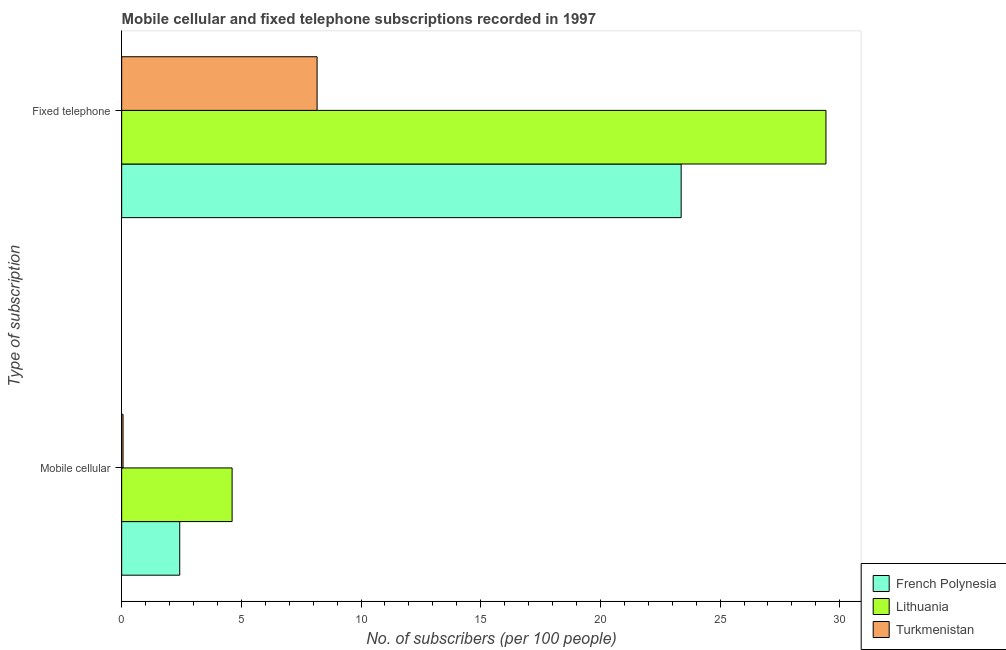Are the number of bars per tick equal to the number of legend labels?
Offer a terse response. Yes. What is the label of the 2nd group of bars from the top?
Keep it short and to the point. Mobile cellular. What is the number of fixed telephone subscribers in Lithuania?
Your answer should be compact. 29.42. Across all countries, what is the maximum number of fixed telephone subscribers?
Your answer should be very brief. 29.42. Across all countries, what is the minimum number of fixed telephone subscribers?
Keep it short and to the point. 8.16. In which country was the number of fixed telephone subscribers maximum?
Give a very brief answer. Lithuania. In which country was the number of fixed telephone subscribers minimum?
Your answer should be compact. Turkmenistan. What is the total number of mobile cellular subscribers in the graph?
Offer a very short reply. 7.1. What is the difference between the number of mobile cellular subscribers in French Polynesia and that in Lithuania?
Give a very brief answer. -2.19. What is the difference between the number of mobile cellular subscribers in Turkmenistan and the number of fixed telephone subscribers in Lithuania?
Your answer should be compact. -29.37. What is the average number of mobile cellular subscribers per country?
Provide a succinct answer. 2.37. What is the difference between the number of fixed telephone subscribers and number of mobile cellular subscribers in Turkmenistan?
Offer a very short reply. 8.11. In how many countries, is the number of fixed telephone subscribers greater than 19 ?
Give a very brief answer. 2. What is the ratio of the number of fixed telephone subscribers in Turkmenistan to that in French Polynesia?
Offer a very short reply. 0.35. Is the number of mobile cellular subscribers in Lithuania less than that in French Polynesia?
Provide a succinct answer. No. In how many countries, is the number of mobile cellular subscribers greater than the average number of mobile cellular subscribers taken over all countries?
Provide a succinct answer. 2. What does the 2nd bar from the top in Mobile cellular represents?
Offer a very short reply. Lithuania. What does the 1st bar from the bottom in Mobile cellular represents?
Offer a terse response. French Polynesia. Are all the bars in the graph horizontal?
Provide a succinct answer. Yes. How many countries are there in the graph?
Keep it short and to the point. 3. What is the difference between two consecutive major ticks on the X-axis?
Offer a very short reply. 5. Does the graph contain any zero values?
Offer a very short reply. No. Does the graph contain grids?
Your answer should be very brief. No. What is the title of the graph?
Your answer should be very brief. Mobile cellular and fixed telephone subscriptions recorded in 1997. What is the label or title of the X-axis?
Provide a short and direct response. No. of subscribers (per 100 people). What is the label or title of the Y-axis?
Provide a succinct answer. Type of subscription. What is the No. of subscribers (per 100 people) of French Polynesia in Mobile cellular?
Make the answer very short. 2.43. What is the No. of subscribers (per 100 people) in Lithuania in Mobile cellular?
Make the answer very short. 4.61. What is the No. of subscribers (per 100 people) in Turkmenistan in Mobile cellular?
Provide a short and direct response. 0.06. What is the No. of subscribers (per 100 people) in French Polynesia in Fixed telephone?
Give a very brief answer. 23.37. What is the No. of subscribers (per 100 people) of Lithuania in Fixed telephone?
Provide a succinct answer. 29.42. What is the No. of subscribers (per 100 people) in Turkmenistan in Fixed telephone?
Your answer should be very brief. 8.16. Across all Type of subscription, what is the maximum No. of subscribers (per 100 people) in French Polynesia?
Your response must be concise. 23.37. Across all Type of subscription, what is the maximum No. of subscribers (per 100 people) of Lithuania?
Offer a very short reply. 29.42. Across all Type of subscription, what is the maximum No. of subscribers (per 100 people) in Turkmenistan?
Your answer should be very brief. 8.16. Across all Type of subscription, what is the minimum No. of subscribers (per 100 people) in French Polynesia?
Your answer should be very brief. 2.43. Across all Type of subscription, what is the minimum No. of subscribers (per 100 people) of Lithuania?
Provide a succinct answer. 4.61. Across all Type of subscription, what is the minimum No. of subscribers (per 100 people) of Turkmenistan?
Offer a very short reply. 0.06. What is the total No. of subscribers (per 100 people) of French Polynesia in the graph?
Provide a short and direct response. 25.8. What is the total No. of subscribers (per 100 people) of Lithuania in the graph?
Your response must be concise. 34.04. What is the total No. of subscribers (per 100 people) of Turkmenistan in the graph?
Keep it short and to the point. 8.22. What is the difference between the No. of subscribers (per 100 people) of French Polynesia in Mobile cellular and that in Fixed telephone?
Your answer should be compact. -20.95. What is the difference between the No. of subscribers (per 100 people) of Lithuania in Mobile cellular and that in Fixed telephone?
Keep it short and to the point. -24.81. What is the difference between the No. of subscribers (per 100 people) in Turkmenistan in Mobile cellular and that in Fixed telephone?
Offer a terse response. -8.11. What is the difference between the No. of subscribers (per 100 people) of French Polynesia in Mobile cellular and the No. of subscribers (per 100 people) of Lithuania in Fixed telephone?
Provide a short and direct response. -27. What is the difference between the No. of subscribers (per 100 people) in French Polynesia in Mobile cellular and the No. of subscribers (per 100 people) in Turkmenistan in Fixed telephone?
Your answer should be compact. -5.74. What is the difference between the No. of subscribers (per 100 people) in Lithuania in Mobile cellular and the No. of subscribers (per 100 people) in Turkmenistan in Fixed telephone?
Give a very brief answer. -3.55. What is the average No. of subscribers (per 100 people) in French Polynesia per Type of subscription?
Provide a short and direct response. 12.9. What is the average No. of subscribers (per 100 people) in Lithuania per Type of subscription?
Your response must be concise. 17.02. What is the average No. of subscribers (per 100 people) in Turkmenistan per Type of subscription?
Make the answer very short. 4.11. What is the difference between the No. of subscribers (per 100 people) in French Polynesia and No. of subscribers (per 100 people) in Lithuania in Mobile cellular?
Your response must be concise. -2.19. What is the difference between the No. of subscribers (per 100 people) in French Polynesia and No. of subscribers (per 100 people) in Turkmenistan in Mobile cellular?
Give a very brief answer. 2.37. What is the difference between the No. of subscribers (per 100 people) in Lithuania and No. of subscribers (per 100 people) in Turkmenistan in Mobile cellular?
Make the answer very short. 4.56. What is the difference between the No. of subscribers (per 100 people) in French Polynesia and No. of subscribers (per 100 people) in Lithuania in Fixed telephone?
Your answer should be very brief. -6.05. What is the difference between the No. of subscribers (per 100 people) of French Polynesia and No. of subscribers (per 100 people) of Turkmenistan in Fixed telephone?
Make the answer very short. 15.21. What is the difference between the No. of subscribers (per 100 people) of Lithuania and No. of subscribers (per 100 people) of Turkmenistan in Fixed telephone?
Give a very brief answer. 21.26. What is the ratio of the No. of subscribers (per 100 people) in French Polynesia in Mobile cellular to that in Fixed telephone?
Give a very brief answer. 0.1. What is the ratio of the No. of subscribers (per 100 people) of Lithuania in Mobile cellular to that in Fixed telephone?
Your answer should be very brief. 0.16. What is the ratio of the No. of subscribers (per 100 people) in Turkmenistan in Mobile cellular to that in Fixed telephone?
Give a very brief answer. 0.01. What is the difference between the highest and the second highest No. of subscribers (per 100 people) of French Polynesia?
Offer a terse response. 20.95. What is the difference between the highest and the second highest No. of subscribers (per 100 people) of Lithuania?
Your answer should be very brief. 24.81. What is the difference between the highest and the second highest No. of subscribers (per 100 people) in Turkmenistan?
Your answer should be compact. 8.11. What is the difference between the highest and the lowest No. of subscribers (per 100 people) of French Polynesia?
Your answer should be very brief. 20.95. What is the difference between the highest and the lowest No. of subscribers (per 100 people) in Lithuania?
Provide a succinct answer. 24.81. What is the difference between the highest and the lowest No. of subscribers (per 100 people) of Turkmenistan?
Make the answer very short. 8.11. 